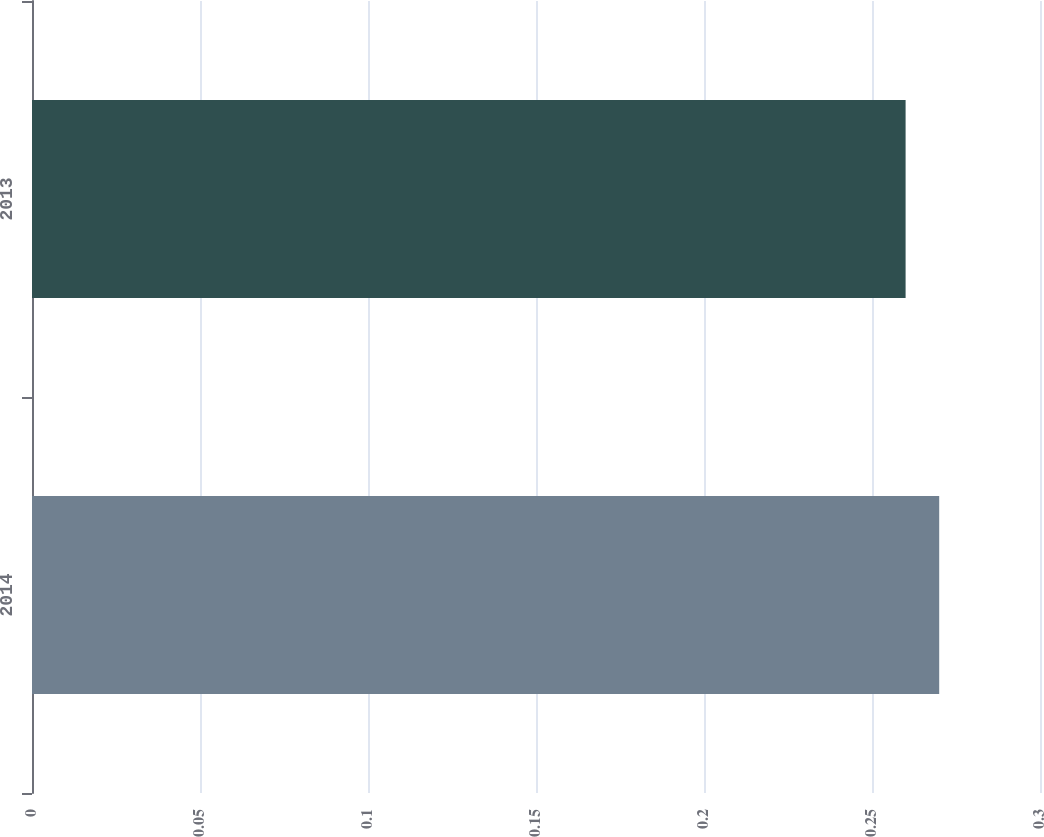Convert chart to OTSL. <chart><loc_0><loc_0><loc_500><loc_500><bar_chart><fcel>2014<fcel>2013<nl><fcel>0.27<fcel>0.26<nl></chart> 